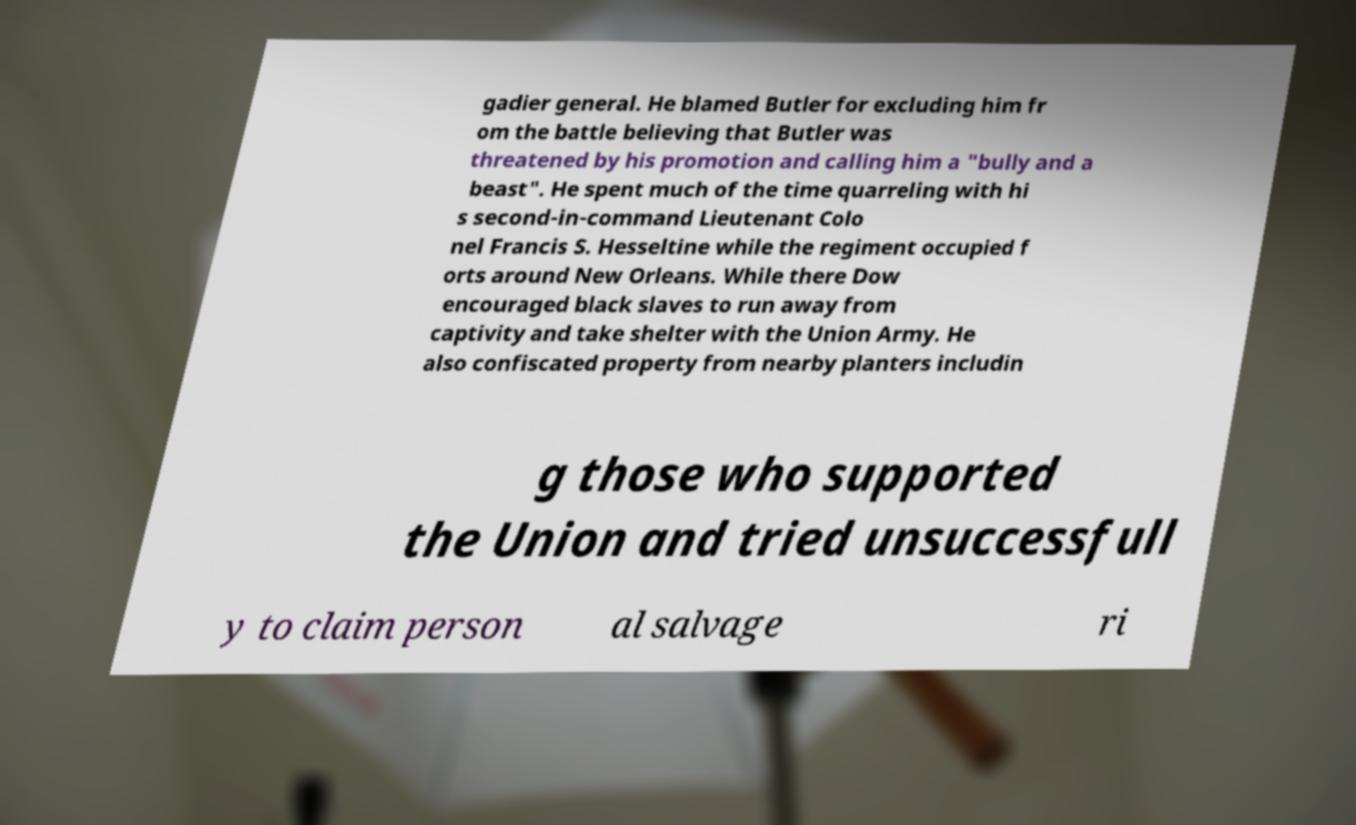Please read and relay the text visible in this image. What does it say? gadier general. He blamed Butler for excluding him fr om the battle believing that Butler was threatened by his promotion and calling him a "bully and a beast". He spent much of the time quarreling with hi s second-in-command Lieutenant Colo nel Francis S. Hesseltine while the regiment occupied f orts around New Orleans. While there Dow encouraged black slaves to run away from captivity and take shelter with the Union Army. He also confiscated property from nearby planters includin g those who supported the Union and tried unsuccessfull y to claim person al salvage ri 